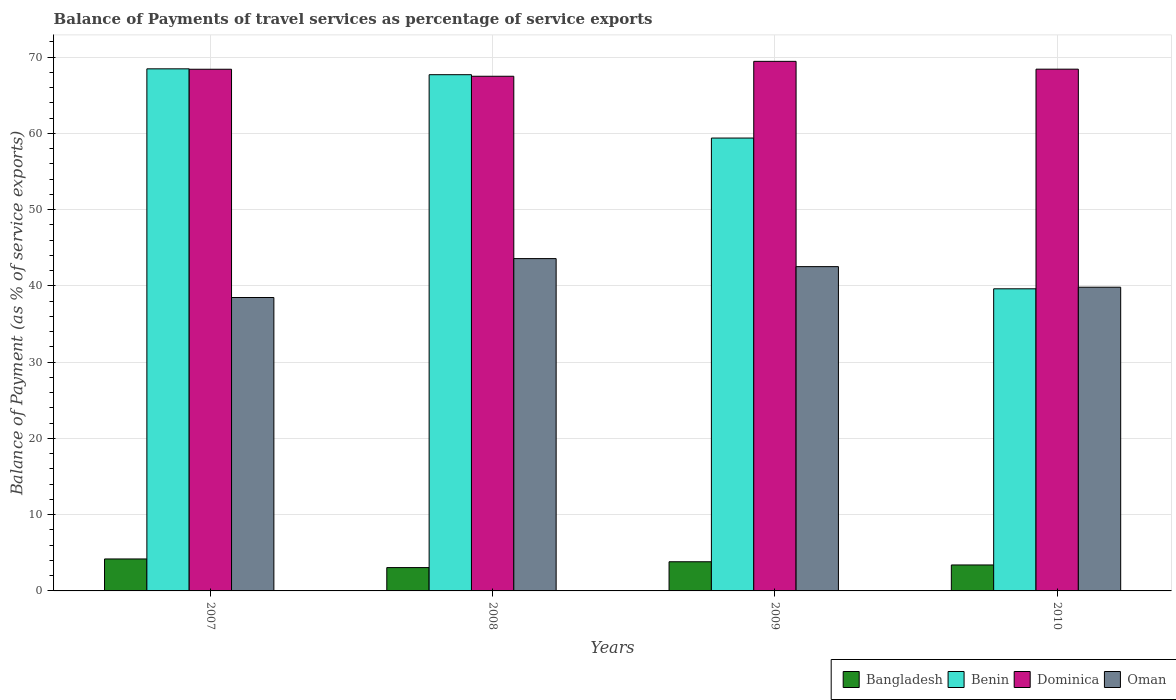How many groups of bars are there?
Offer a terse response. 4. Are the number of bars per tick equal to the number of legend labels?
Provide a succinct answer. Yes. Are the number of bars on each tick of the X-axis equal?
Provide a succinct answer. Yes. How many bars are there on the 2nd tick from the left?
Your answer should be compact. 4. What is the label of the 1st group of bars from the left?
Offer a terse response. 2007. What is the balance of payments of travel services in Dominica in 2010?
Ensure brevity in your answer.  68.44. Across all years, what is the maximum balance of payments of travel services in Oman?
Your response must be concise. 43.59. Across all years, what is the minimum balance of payments of travel services in Dominica?
Provide a succinct answer. 67.51. In which year was the balance of payments of travel services in Benin maximum?
Give a very brief answer. 2007. What is the total balance of payments of travel services in Benin in the graph?
Provide a succinct answer. 235.22. What is the difference between the balance of payments of travel services in Benin in 2007 and that in 2010?
Ensure brevity in your answer.  28.85. What is the difference between the balance of payments of travel services in Dominica in 2007 and the balance of payments of travel services in Benin in 2009?
Ensure brevity in your answer.  9.03. What is the average balance of payments of travel services in Bangladesh per year?
Give a very brief answer. 3.62. In the year 2010, what is the difference between the balance of payments of travel services in Oman and balance of payments of travel services in Bangladesh?
Provide a short and direct response. 36.43. In how many years, is the balance of payments of travel services in Dominica greater than 16 %?
Keep it short and to the point. 4. What is the ratio of the balance of payments of travel services in Benin in 2007 to that in 2008?
Provide a succinct answer. 1.01. What is the difference between the highest and the second highest balance of payments of travel services in Dominica?
Your answer should be compact. 1.02. What is the difference between the highest and the lowest balance of payments of travel services in Benin?
Make the answer very short. 28.85. In how many years, is the balance of payments of travel services in Dominica greater than the average balance of payments of travel services in Dominica taken over all years?
Ensure brevity in your answer.  1. What does the 2nd bar from the left in 2008 represents?
Offer a terse response. Benin. What does the 1st bar from the right in 2007 represents?
Provide a short and direct response. Oman. Is it the case that in every year, the sum of the balance of payments of travel services in Benin and balance of payments of travel services in Dominica is greater than the balance of payments of travel services in Bangladesh?
Your response must be concise. Yes. Are all the bars in the graph horizontal?
Your response must be concise. No. Are the values on the major ticks of Y-axis written in scientific E-notation?
Give a very brief answer. No. Where does the legend appear in the graph?
Provide a short and direct response. Bottom right. What is the title of the graph?
Keep it short and to the point. Balance of Payments of travel services as percentage of service exports. What is the label or title of the Y-axis?
Provide a succinct answer. Balance of Payment (as % of service exports). What is the Balance of Payment (as % of service exports) in Bangladesh in 2007?
Offer a very short reply. 4.19. What is the Balance of Payment (as % of service exports) of Benin in 2007?
Keep it short and to the point. 68.48. What is the Balance of Payment (as % of service exports) of Dominica in 2007?
Provide a succinct answer. 68.43. What is the Balance of Payment (as % of service exports) of Oman in 2007?
Provide a short and direct response. 38.49. What is the Balance of Payment (as % of service exports) in Bangladesh in 2008?
Ensure brevity in your answer.  3.06. What is the Balance of Payment (as % of service exports) in Benin in 2008?
Make the answer very short. 67.71. What is the Balance of Payment (as % of service exports) in Dominica in 2008?
Offer a terse response. 67.51. What is the Balance of Payment (as % of service exports) in Oman in 2008?
Offer a very short reply. 43.59. What is the Balance of Payment (as % of service exports) of Bangladesh in 2009?
Your answer should be compact. 3.83. What is the Balance of Payment (as % of service exports) of Benin in 2009?
Your answer should be compact. 59.4. What is the Balance of Payment (as % of service exports) of Dominica in 2009?
Offer a terse response. 69.46. What is the Balance of Payment (as % of service exports) of Oman in 2009?
Provide a succinct answer. 42.54. What is the Balance of Payment (as % of service exports) of Bangladesh in 2010?
Offer a very short reply. 3.4. What is the Balance of Payment (as % of service exports) of Benin in 2010?
Your answer should be compact. 39.63. What is the Balance of Payment (as % of service exports) of Dominica in 2010?
Your response must be concise. 68.44. What is the Balance of Payment (as % of service exports) in Oman in 2010?
Your answer should be compact. 39.84. Across all years, what is the maximum Balance of Payment (as % of service exports) of Bangladesh?
Provide a short and direct response. 4.19. Across all years, what is the maximum Balance of Payment (as % of service exports) of Benin?
Ensure brevity in your answer.  68.48. Across all years, what is the maximum Balance of Payment (as % of service exports) in Dominica?
Offer a very short reply. 69.46. Across all years, what is the maximum Balance of Payment (as % of service exports) in Oman?
Give a very brief answer. 43.59. Across all years, what is the minimum Balance of Payment (as % of service exports) of Bangladesh?
Your response must be concise. 3.06. Across all years, what is the minimum Balance of Payment (as % of service exports) of Benin?
Your answer should be compact. 39.63. Across all years, what is the minimum Balance of Payment (as % of service exports) in Dominica?
Provide a succinct answer. 67.51. Across all years, what is the minimum Balance of Payment (as % of service exports) in Oman?
Offer a terse response. 38.49. What is the total Balance of Payment (as % of service exports) in Bangladesh in the graph?
Keep it short and to the point. 14.48. What is the total Balance of Payment (as % of service exports) of Benin in the graph?
Provide a succinct answer. 235.22. What is the total Balance of Payment (as % of service exports) in Dominica in the graph?
Keep it short and to the point. 273.83. What is the total Balance of Payment (as % of service exports) in Oman in the graph?
Your answer should be very brief. 164.45. What is the difference between the Balance of Payment (as % of service exports) in Bangladesh in 2007 and that in 2008?
Keep it short and to the point. 1.13. What is the difference between the Balance of Payment (as % of service exports) of Benin in 2007 and that in 2008?
Ensure brevity in your answer.  0.77. What is the difference between the Balance of Payment (as % of service exports) in Dominica in 2007 and that in 2008?
Give a very brief answer. 0.92. What is the difference between the Balance of Payment (as % of service exports) of Oman in 2007 and that in 2008?
Offer a very short reply. -5.1. What is the difference between the Balance of Payment (as % of service exports) of Bangladesh in 2007 and that in 2009?
Offer a very short reply. 0.37. What is the difference between the Balance of Payment (as % of service exports) in Benin in 2007 and that in 2009?
Keep it short and to the point. 9.08. What is the difference between the Balance of Payment (as % of service exports) of Dominica in 2007 and that in 2009?
Your response must be concise. -1.04. What is the difference between the Balance of Payment (as % of service exports) of Oman in 2007 and that in 2009?
Ensure brevity in your answer.  -4.05. What is the difference between the Balance of Payment (as % of service exports) in Bangladesh in 2007 and that in 2010?
Provide a short and direct response. 0.79. What is the difference between the Balance of Payment (as % of service exports) of Benin in 2007 and that in 2010?
Your response must be concise. 28.85. What is the difference between the Balance of Payment (as % of service exports) of Dominica in 2007 and that in 2010?
Make the answer very short. -0.01. What is the difference between the Balance of Payment (as % of service exports) in Oman in 2007 and that in 2010?
Ensure brevity in your answer.  -1.35. What is the difference between the Balance of Payment (as % of service exports) in Bangladesh in 2008 and that in 2009?
Keep it short and to the point. -0.77. What is the difference between the Balance of Payment (as % of service exports) of Benin in 2008 and that in 2009?
Give a very brief answer. 8.31. What is the difference between the Balance of Payment (as % of service exports) of Dominica in 2008 and that in 2009?
Ensure brevity in your answer.  -1.96. What is the difference between the Balance of Payment (as % of service exports) of Oman in 2008 and that in 2009?
Your response must be concise. 1.05. What is the difference between the Balance of Payment (as % of service exports) of Bangladesh in 2008 and that in 2010?
Offer a very short reply. -0.34. What is the difference between the Balance of Payment (as % of service exports) of Benin in 2008 and that in 2010?
Give a very brief answer. 28.08. What is the difference between the Balance of Payment (as % of service exports) of Dominica in 2008 and that in 2010?
Keep it short and to the point. -0.93. What is the difference between the Balance of Payment (as % of service exports) in Oman in 2008 and that in 2010?
Provide a succinct answer. 3.75. What is the difference between the Balance of Payment (as % of service exports) in Bangladesh in 2009 and that in 2010?
Offer a very short reply. 0.42. What is the difference between the Balance of Payment (as % of service exports) in Benin in 2009 and that in 2010?
Provide a succinct answer. 19.77. What is the difference between the Balance of Payment (as % of service exports) of Dominica in 2009 and that in 2010?
Give a very brief answer. 1.02. What is the difference between the Balance of Payment (as % of service exports) of Oman in 2009 and that in 2010?
Your answer should be compact. 2.7. What is the difference between the Balance of Payment (as % of service exports) of Bangladesh in 2007 and the Balance of Payment (as % of service exports) of Benin in 2008?
Offer a very short reply. -63.52. What is the difference between the Balance of Payment (as % of service exports) of Bangladesh in 2007 and the Balance of Payment (as % of service exports) of Dominica in 2008?
Offer a terse response. -63.31. What is the difference between the Balance of Payment (as % of service exports) of Bangladesh in 2007 and the Balance of Payment (as % of service exports) of Oman in 2008?
Your response must be concise. -39.4. What is the difference between the Balance of Payment (as % of service exports) of Benin in 2007 and the Balance of Payment (as % of service exports) of Dominica in 2008?
Your answer should be very brief. 0.97. What is the difference between the Balance of Payment (as % of service exports) in Benin in 2007 and the Balance of Payment (as % of service exports) in Oman in 2008?
Provide a succinct answer. 24.89. What is the difference between the Balance of Payment (as % of service exports) in Dominica in 2007 and the Balance of Payment (as % of service exports) in Oman in 2008?
Your answer should be very brief. 24.84. What is the difference between the Balance of Payment (as % of service exports) of Bangladesh in 2007 and the Balance of Payment (as % of service exports) of Benin in 2009?
Your response must be concise. -55.21. What is the difference between the Balance of Payment (as % of service exports) of Bangladesh in 2007 and the Balance of Payment (as % of service exports) of Dominica in 2009?
Provide a short and direct response. -65.27. What is the difference between the Balance of Payment (as % of service exports) in Bangladesh in 2007 and the Balance of Payment (as % of service exports) in Oman in 2009?
Your response must be concise. -38.34. What is the difference between the Balance of Payment (as % of service exports) in Benin in 2007 and the Balance of Payment (as % of service exports) in Dominica in 2009?
Provide a short and direct response. -0.98. What is the difference between the Balance of Payment (as % of service exports) of Benin in 2007 and the Balance of Payment (as % of service exports) of Oman in 2009?
Ensure brevity in your answer.  25.94. What is the difference between the Balance of Payment (as % of service exports) in Dominica in 2007 and the Balance of Payment (as % of service exports) in Oman in 2009?
Your answer should be very brief. 25.89. What is the difference between the Balance of Payment (as % of service exports) in Bangladesh in 2007 and the Balance of Payment (as % of service exports) in Benin in 2010?
Your answer should be very brief. -35.43. What is the difference between the Balance of Payment (as % of service exports) in Bangladesh in 2007 and the Balance of Payment (as % of service exports) in Dominica in 2010?
Your answer should be very brief. -64.24. What is the difference between the Balance of Payment (as % of service exports) in Bangladesh in 2007 and the Balance of Payment (as % of service exports) in Oman in 2010?
Your answer should be compact. -35.64. What is the difference between the Balance of Payment (as % of service exports) of Benin in 2007 and the Balance of Payment (as % of service exports) of Dominica in 2010?
Make the answer very short. 0.04. What is the difference between the Balance of Payment (as % of service exports) in Benin in 2007 and the Balance of Payment (as % of service exports) in Oman in 2010?
Provide a succinct answer. 28.64. What is the difference between the Balance of Payment (as % of service exports) of Dominica in 2007 and the Balance of Payment (as % of service exports) of Oman in 2010?
Your answer should be compact. 28.59. What is the difference between the Balance of Payment (as % of service exports) of Bangladesh in 2008 and the Balance of Payment (as % of service exports) of Benin in 2009?
Offer a very short reply. -56.34. What is the difference between the Balance of Payment (as % of service exports) in Bangladesh in 2008 and the Balance of Payment (as % of service exports) in Dominica in 2009?
Your answer should be compact. -66.4. What is the difference between the Balance of Payment (as % of service exports) in Bangladesh in 2008 and the Balance of Payment (as % of service exports) in Oman in 2009?
Make the answer very short. -39.48. What is the difference between the Balance of Payment (as % of service exports) of Benin in 2008 and the Balance of Payment (as % of service exports) of Dominica in 2009?
Your answer should be very brief. -1.75. What is the difference between the Balance of Payment (as % of service exports) in Benin in 2008 and the Balance of Payment (as % of service exports) in Oman in 2009?
Your answer should be compact. 25.17. What is the difference between the Balance of Payment (as % of service exports) in Dominica in 2008 and the Balance of Payment (as % of service exports) in Oman in 2009?
Make the answer very short. 24.97. What is the difference between the Balance of Payment (as % of service exports) of Bangladesh in 2008 and the Balance of Payment (as % of service exports) of Benin in 2010?
Your response must be concise. -36.57. What is the difference between the Balance of Payment (as % of service exports) in Bangladesh in 2008 and the Balance of Payment (as % of service exports) in Dominica in 2010?
Give a very brief answer. -65.38. What is the difference between the Balance of Payment (as % of service exports) in Bangladesh in 2008 and the Balance of Payment (as % of service exports) in Oman in 2010?
Provide a short and direct response. -36.78. What is the difference between the Balance of Payment (as % of service exports) of Benin in 2008 and the Balance of Payment (as % of service exports) of Dominica in 2010?
Your response must be concise. -0.73. What is the difference between the Balance of Payment (as % of service exports) in Benin in 2008 and the Balance of Payment (as % of service exports) in Oman in 2010?
Ensure brevity in your answer.  27.87. What is the difference between the Balance of Payment (as % of service exports) of Dominica in 2008 and the Balance of Payment (as % of service exports) of Oman in 2010?
Your answer should be very brief. 27.67. What is the difference between the Balance of Payment (as % of service exports) of Bangladesh in 2009 and the Balance of Payment (as % of service exports) of Benin in 2010?
Your response must be concise. -35.8. What is the difference between the Balance of Payment (as % of service exports) of Bangladesh in 2009 and the Balance of Payment (as % of service exports) of Dominica in 2010?
Provide a short and direct response. -64.61. What is the difference between the Balance of Payment (as % of service exports) of Bangladesh in 2009 and the Balance of Payment (as % of service exports) of Oman in 2010?
Offer a terse response. -36.01. What is the difference between the Balance of Payment (as % of service exports) of Benin in 2009 and the Balance of Payment (as % of service exports) of Dominica in 2010?
Give a very brief answer. -9.04. What is the difference between the Balance of Payment (as % of service exports) of Benin in 2009 and the Balance of Payment (as % of service exports) of Oman in 2010?
Offer a very short reply. 19.56. What is the difference between the Balance of Payment (as % of service exports) of Dominica in 2009 and the Balance of Payment (as % of service exports) of Oman in 2010?
Offer a terse response. 29.62. What is the average Balance of Payment (as % of service exports) of Bangladesh per year?
Provide a short and direct response. 3.62. What is the average Balance of Payment (as % of service exports) in Benin per year?
Make the answer very short. 58.8. What is the average Balance of Payment (as % of service exports) in Dominica per year?
Keep it short and to the point. 68.46. What is the average Balance of Payment (as % of service exports) in Oman per year?
Your answer should be very brief. 41.11. In the year 2007, what is the difference between the Balance of Payment (as % of service exports) of Bangladesh and Balance of Payment (as % of service exports) of Benin?
Offer a very short reply. -64.29. In the year 2007, what is the difference between the Balance of Payment (as % of service exports) of Bangladesh and Balance of Payment (as % of service exports) of Dominica?
Offer a terse response. -64.23. In the year 2007, what is the difference between the Balance of Payment (as % of service exports) in Bangladesh and Balance of Payment (as % of service exports) in Oman?
Your response must be concise. -34.29. In the year 2007, what is the difference between the Balance of Payment (as % of service exports) in Benin and Balance of Payment (as % of service exports) in Dominica?
Make the answer very short. 0.05. In the year 2007, what is the difference between the Balance of Payment (as % of service exports) in Benin and Balance of Payment (as % of service exports) in Oman?
Offer a terse response. 29.99. In the year 2007, what is the difference between the Balance of Payment (as % of service exports) in Dominica and Balance of Payment (as % of service exports) in Oman?
Offer a terse response. 29.94. In the year 2008, what is the difference between the Balance of Payment (as % of service exports) of Bangladesh and Balance of Payment (as % of service exports) of Benin?
Your answer should be compact. -64.65. In the year 2008, what is the difference between the Balance of Payment (as % of service exports) in Bangladesh and Balance of Payment (as % of service exports) in Dominica?
Your response must be concise. -64.45. In the year 2008, what is the difference between the Balance of Payment (as % of service exports) of Bangladesh and Balance of Payment (as % of service exports) of Oman?
Provide a short and direct response. -40.53. In the year 2008, what is the difference between the Balance of Payment (as % of service exports) of Benin and Balance of Payment (as % of service exports) of Dominica?
Ensure brevity in your answer.  0.21. In the year 2008, what is the difference between the Balance of Payment (as % of service exports) of Benin and Balance of Payment (as % of service exports) of Oman?
Provide a succinct answer. 24.12. In the year 2008, what is the difference between the Balance of Payment (as % of service exports) in Dominica and Balance of Payment (as % of service exports) in Oman?
Offer a very short reply. 23.92. In the year 2009, what is the difference between the Balance of Payment (as % of service exports) of Bangladesh and Balance of Payment (as % of service exports) of Benin?
Keep it short and to the point. -55.57. In the year 2009, what is the difference between the Balance of Payment (as % of service exports) of Bangladesh and Balance of Payment (as % of service exports) of Dominica?
Offer a terse response. -65.64. In the year 2009, what is the difference between the Balance of Payment (as % of service exports) in Bangladesh and Balance of Payment (as % of service exports) in Oman?
Make the answer very short. -38.71. In the year 2009, what is the difference between the Balance of Payment (as % of service exports) of Benin and Balance of Payment (as % of service exports) of Dominica?
Offer a terse response. -10.06. In the year 2009, what is the difference between the Balance of Payment (as % of service exports) in Benin and Balance of Payment (as % of service exports) in Oman?
Your response must be concise. 16.86. In the year 2009, what is the difference between the Balance of Payment (as % of service exports) in Dominica and Balance of Payment (as % of service exports) in Oman?
Offer a very short reply. 26.93. In the year 2010, what is the difference between the Balance of Payment (as % of service exports) of Bangladesh and Balance of Payment (as % of service exports) of Benin?
Ensure brevity in your answer.  -36.22. In the year 2010, what is the difference between the Balance of Payment (as % of service exports) in Bangladesh and Balance of Payment (as % of service exports) in Dominica?
Your answer should be very brief. -65.03. In the year 2010, what is the difference between the Balance of Payment (as % of service exports) of Bangladesh and Balance of Payment (as % of service exports) of Oman?
Keep it short and to the point. -36.43. In the year 2010, what is the difference between the Balance of Payment (as % of service exports) in Benin and Balance of Payment (as % of service exports) in Dominica?
Give a very brief answer. -28.81. In the year 2010, what is the difference between the Balance of Payment (as % of service exports) in Benin and Balance of Payment (as % of service exports) in Oman?
Provide a short and direct response. -0.21. In the year 2010, what is the difference between the Balance of Payment (as % of service exports) of Dominica and Balance of Payment (as % of service exports) of Oman?
Provide a succinct answer. 28.6. What is the ratio of the Balance of Payment (as % of service exports) of Bangladesh in 2007 to that in 2008?
Your answer should be compact. 1.37. What is the ratio of the Balance of Payment (as % of service exports) in Benin in 2007 to that in 2008?
Your answer should be very brief. 1.01. What is the ratio of the Balance of Payment (as % of service exports) in Dominica in 2007 to that in 2008?
Give a very brief answer. 1.01. What is the ratio of the Balance of Payment (as % of service exports) of Oman in 2007 to that in 2008?
Offer a very short reply. 0.88. What is the ratio of the Balance of Payment (as % of service exports) of Bangladesh in 2007 to that in 2009?
Offer a very short reply. 1.1. What is the ratio of the Balance of Payment (as % of service exports) of Benin in 2007 to that in 2009?
Your answer should be compact. 1.15. What is the ratio of the Balance of Payment (as % of service exports) in Dominica in 2007 to that in 2009?
Keep it short and to the point. 0.99. What is the ratio of the Balance of Payment (as % of service exports) of Oman in 2007 to that in 2009?
Provide a short and direct response. 0.9. What is the ratio of the Balance of Payment (as % of service exports) in Bangladesh in 2007 to that in 2010?
Offer a terse response. 1.23. What is the ratio of the Balance of Payment (as % of service exports) in Benin in 2007 to that in 2010?
Make the answer very short. 1.73. What is the ratio of the Balance of Payment (as % of service exports) in Oman in 2007 to that in 2010?
Give a very brief answer. 0.97. What is the ratio of the Balance of Payment (as % of service exports) in Benin in 2008 to that in 2009?
Ensure brevity in your answer.  1.14. What is the ratio of the Balance of Payment (as % of service exports) of Dominica in 2008 to that in 2009?
Your response must be concise. 0.97. What is the ratio of the Balance of Payment (as % of service exports) of Oman in 2008 to that in 2009?
Provide a short and direct response. 1.02. What is the ratio of the Balance of Payment (as % of service exports) in Bangladesh in 2008 to that in 2010?
Ensure brevity in your answer.  0.9. What is the ratio of the Balance of Payment (as % of service exports) in Benin in 2008 to that in 2010?
Keep it short and to the point. 1.71. What is the ratio of the Balance of Payment (as % of service exports) in Dominica in 2008 to that in 2010?
Give a very brief answer. 0.99. What is the ratio of the Balance of Payment (as % of service exports) in Oman in 2008 to that in 2010?
Provide a short and direct response. 1.09. What is the ratio of the Balance of Payment (as % of service exports) of Bangladesh in 2009 to that in 2010?
Provide a succinct answer. 1.12. What is the ratio of the Balance of Payment (as % of service exports) of Benin in 2009 to that in 2010?
Your answer should be compact. 1.5. What is the ratio of the Balance of Payment (as % of service exports) of Dominica in 2009 to that in 2010?
Offer a terse response. 1.01. What is the ratio of the Balance of Payment (as % of service exports) of Oman in 2009 to that in 2010?
Offer a terse response. 1.07. What is the difference between the highest and the second highest Balance of Payment (as % of service exports) of Bangladesh?
Keep it short and to the point. 0.37. What is the difference between the highest and the second highest Balance of Payment (as % of service exports) in Benin?
Offer a terse response. 0.77. What is the difference between the highest and the second highest Balance of Payment (as % of service exports) of Dominica?
Keep it short and to the point. 1.02. What is the difference between the highest and the second highest Balance of Payment (as % of service exports) of Oman?
Your response must be concise. 1.05. What is the difference between the highest and the lowest Balance of Payment (as % of service exports) in Bangladesh?
Offer a very short reply. 1.13. What is the difference between the highest and the lowest Balance of Payment (as % of service exports) in Benin?
Give a very brief answer. 28.85. What is the difference between the highest and the lowest Balance of Payment (as % of service exports) in Dominica?
Ensure brevity in your answer.  1.96. What is the difference between the highest and the lowest Balance of Payment (as % of service exports) in Oman?
Your answer should be very brief. 5.1. 